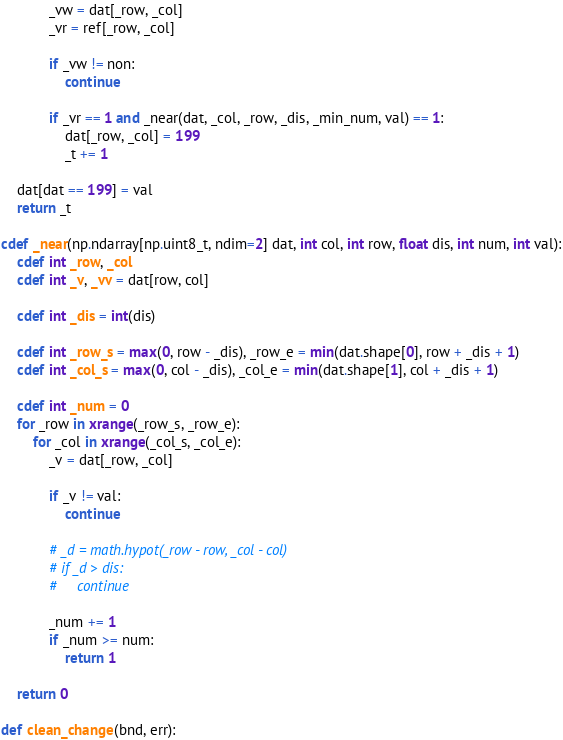<code> <loc_0><loc_0><loc_500><loc_500><_Cython_>            _vw = dat[_row, _col]
            _vr = ref[_row, _col]

            if _vw != non:
                continue

            if _vr == 1 and _near(dat, _col, _row, _dis, _min_num, val) == 1:
                dat[_row, _col] = 199
                _t += 1
    
    dat[dat == 199] = val
    return _t

cdef _near(np.ndarray[np.uint8_t, ndim=2] dat, int col, int row, float dis, int num, int val):
    cdef int _row, _col
    cdef int _v, _vv = dat[row, col]

    cdef int _dis = int(dis)

    cdef int _row_s = max(0, row - _dis), _row_e = min(dat.shape[0], row + _dis + 1)
    cdef int _col_s = max(0, col - _dis), _col_e = min(dat.shape[1], col + _dis + 1)

    cdef int _num = 0
    for _row in xrange(_row_s, _row_e):
        for _col in xrange(_col_s, _col_e):
            _v = dat[_row, _col]

            if _v != val:
                continue

            # _d = math.hypot(_row - row, _col - col)
            # if _d > dis:
            #     continue

            _num += 1
            if _num >= num:
                return 1

    return 0

def clean_change(bnd, err):</code> 